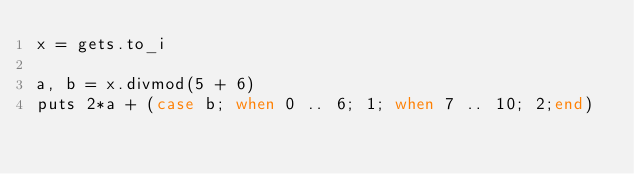<code> <loc_0><loc_0><loc_500><loc_500><_Ruby_>x = gets.to_i

a, b = x.divmod(5 + 6)
puts 2*a + (case b; when 0 .. 6; 1; when 7 .. 10; 2;end)</code> 